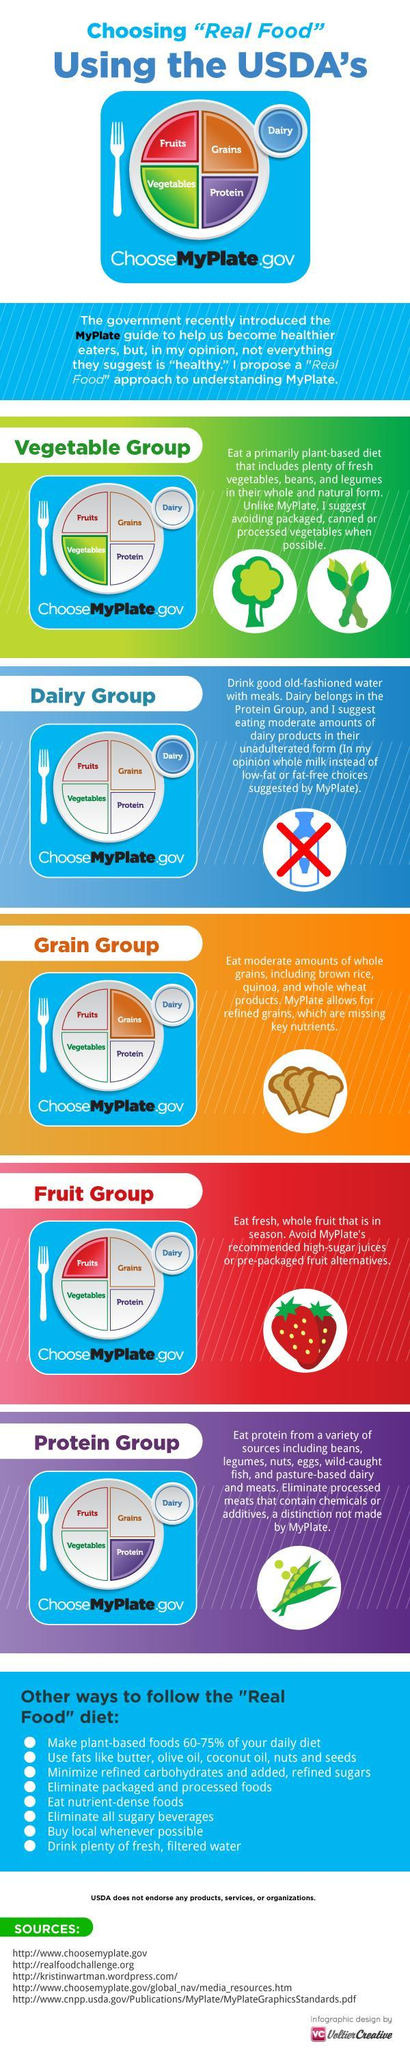Which is the third food group mentioned in this graphic?
Answer the question with a short phrase. Grain group Which food group has an image of strawberries in it? Fruit group Eggs are mentioned under which food group? Protein group Which is the second grain name mentioned in the grain group? quinoa What should be eliminated in the protein category? processed meats 